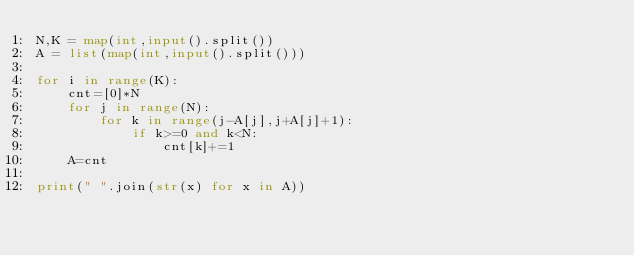<code> <loc_0><loc_0><loc_500><loc_500><_Python_>N,K = map(int,input().split())
A = list(map(int,input().split()))

for i in range(K):
    cnt=[0]*N
    for j in range(N):
        for k in range(j-A[j],j+A[j]+1):
            if k>=0 and k<N:
                cnt[k]+=1
    A=cnt

print(" ".join(str(x) for x in A))</code> 